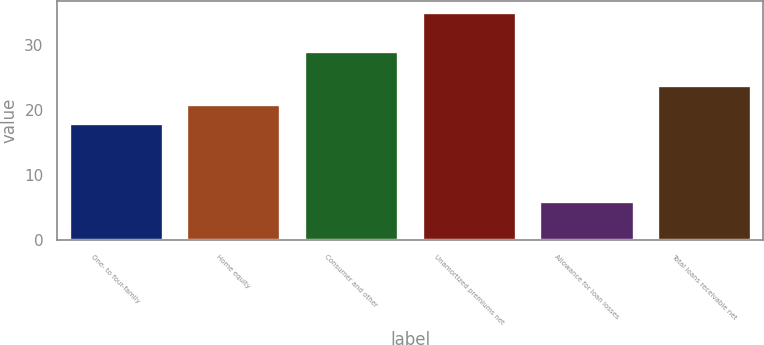<chart> <loc_0><loc_0><loc_500><loc_500><bar_chart><fcel>One- to four-family<fcel>Home equity<fcel>Consumer and other<fcel>Unamortized premiums net<fcel>Allowance for loan losses<fcel>Total loans receivable net<nl><fcel>18<fcel>20.9<fcel>29<fcel>35<fcel>6<fcel>23.8<nl></chart> 